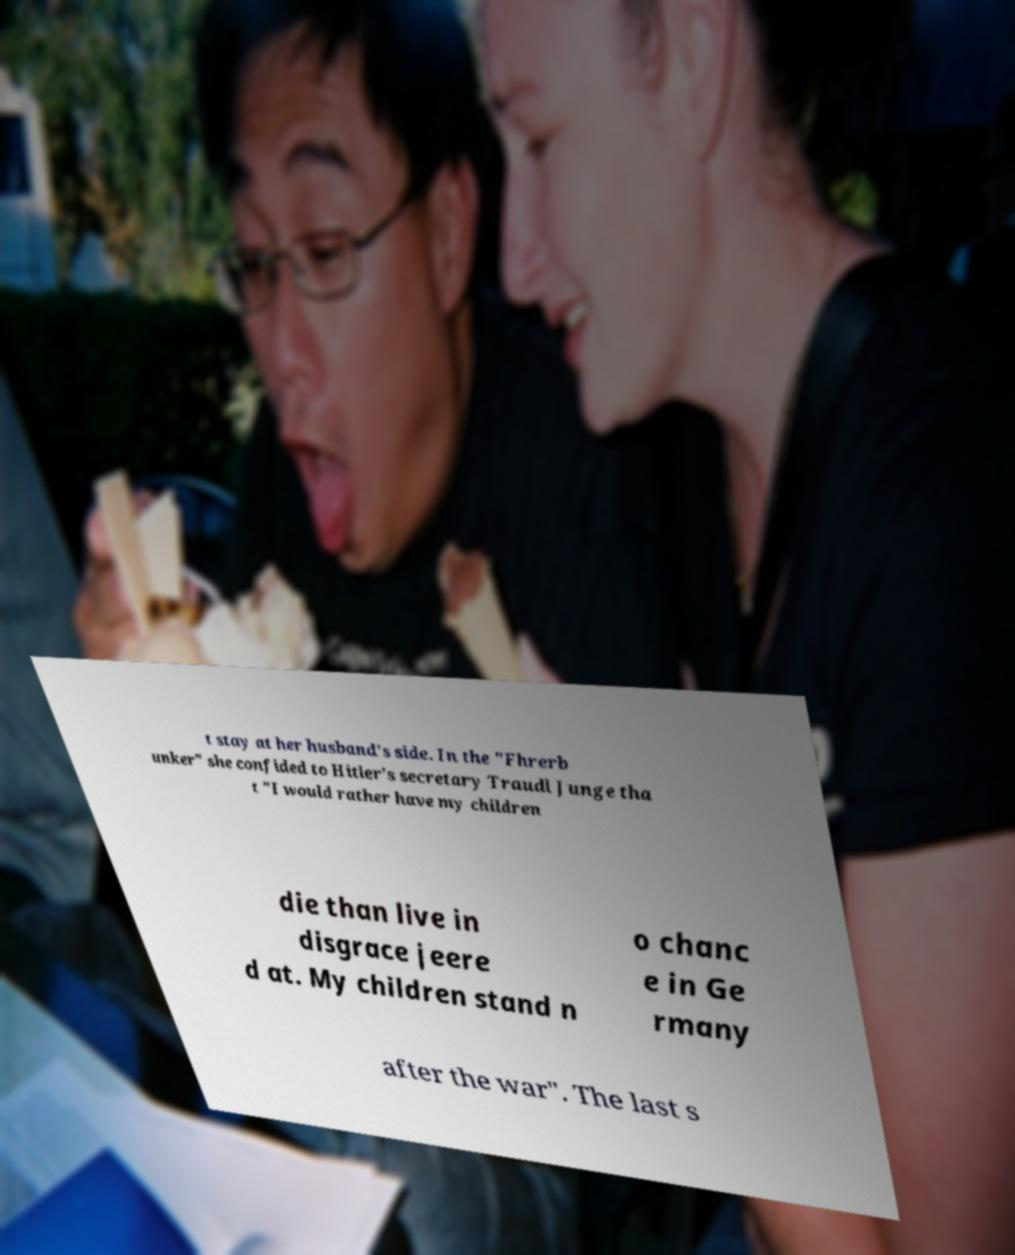Please read and relay the text visible in this image. What does it say? t stay at her husband's side. In the "Fhrerb unker" she confided to Hitler's secretary Traudl Junge tha t "I would rather have my children die than live in disgrace jeere d at. My children stand n o chanc e in Ge rmany after the war". The last s 